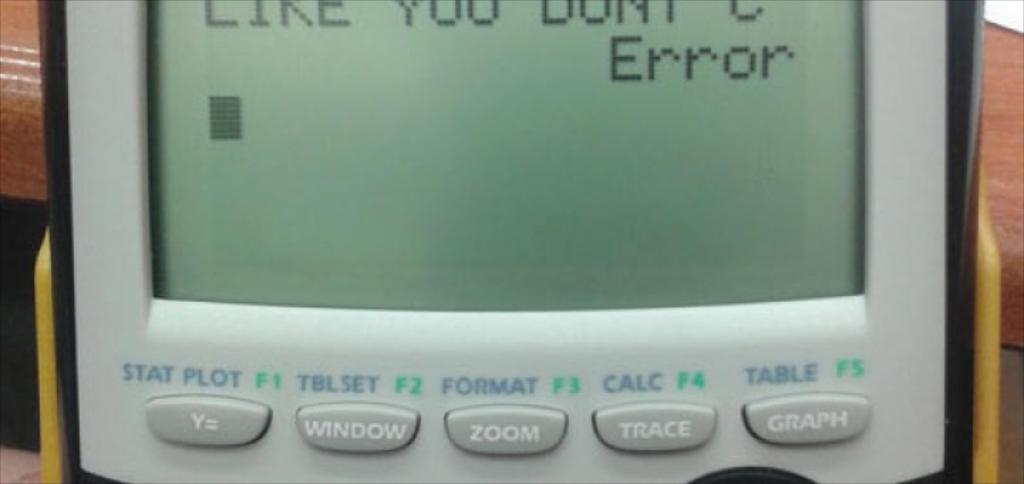What does the last line of the calculator read?
Offer a very short reply. Error. What does the middle button say?
Provide a short and direct response. Zoom. 